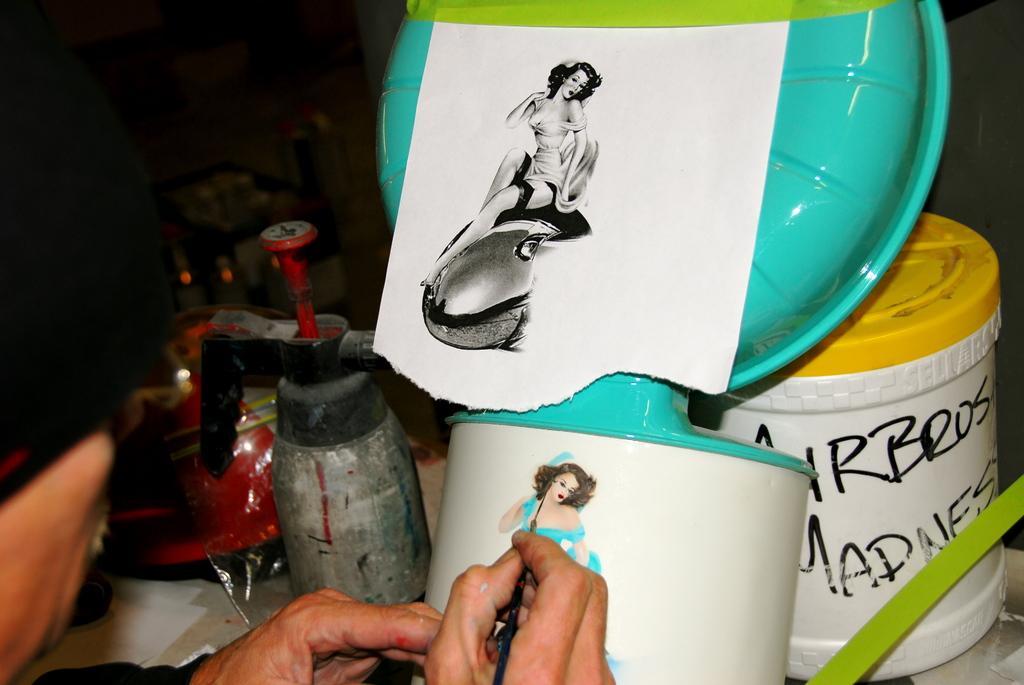How would you summarize this image in a sentence or two? In this picture, it seems like a person, is painting and other objects in the foreground. 